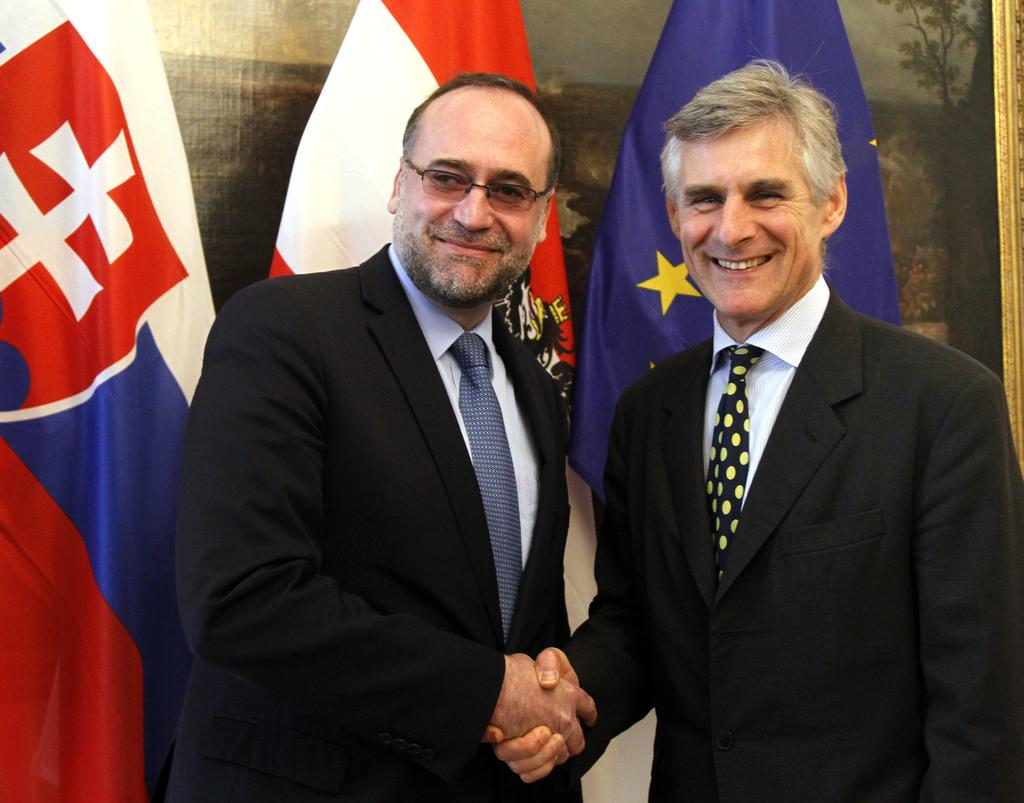How many people are present in the image? There are two persons in the image. What are the two persons doing in the image? The two persons are shaking hands. What can be seen in the background of the image? There are three flags in the background of the image. What type of snail can be seen crawling on the person's hand in the image? There is no snail present in the image; the two persons are shaking hands. What is the name of the downtown area where the image was taken? The location of the image is not mentioned in the provided facts, so it cannot be determined if it was taken in a downtown area or if it has a specific name. 